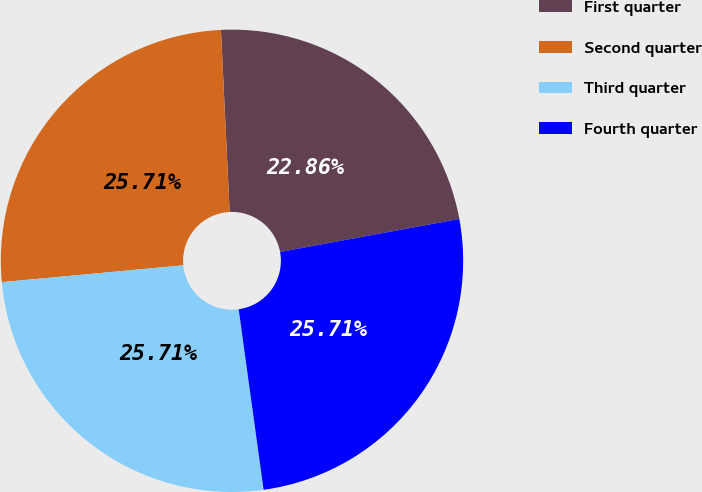<chart> <loc_0><loc_0><loc_500><loc_500><pie_chart><fcel>First quarter<fcel>Second quarter<fcel>Third quarter<fcel>Fourth quarter<nl><fcel>22.86%<fcel>25.71%<fcel>25.71%<fcel>25.71%<nl></chart> 